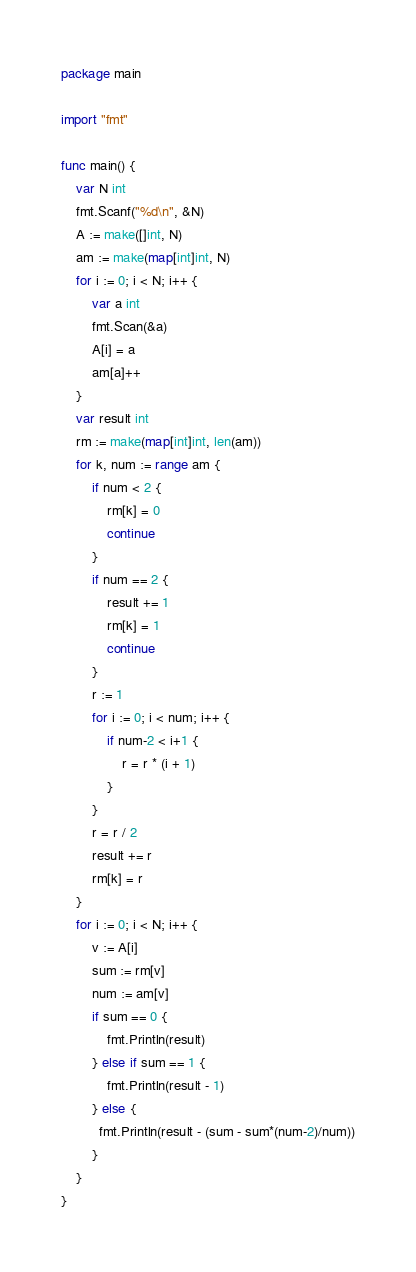<code> <loc_0><loc_0><loc_500><loc_500><_Go_>package main

import "fmt"

func main() {
	var N int
	fmt.Scanf("%d\n", &N)
	A := make([]int, N)
	am := make(map[int]int, N)
	for i := 0; i < N; i++ {
		var a int
		fmt.Scan(&a)
		A[i] = a
		am[a]++
	}
	var result int
	rm := make(map[int]int, len(am))
	for k, num := range am {
		if num < 2 {
			rm[k] = 0
			continue
		}
		if num == 2 {
			result += 1
			rm[k] = 1
			continue
		}
		r := 1
		for i := 0; i < num; i++ {
			if num-2 < i+1 {
				r = r * (i + 1)
			}
		}
		r = r / 2
		result += r
		rm[k] = r
	}
	for i := 0; i < N; i++ {
		v := A[i]
		sum := rm[v]
		num := am[v]
		if sum == 0 {
			fmt.Println(result)
		} else if sum == 1 {
			fmt.Println(result - 1)
		} else {
          fmt.Println(result - (sum - sum*(num-2)/num))
		}
	}
}
</code> 